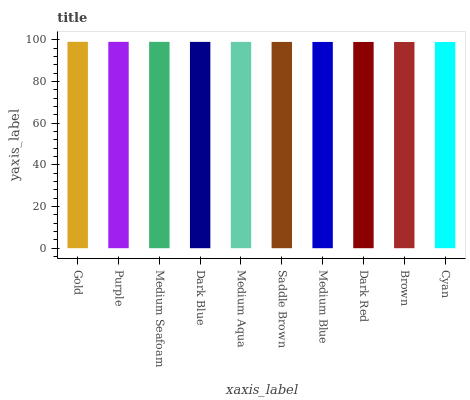Is Cyan the minimum?
Answer yes or no. Yes. Is Gold the maximum?
Answer yes or no. Yes. Is Purple the minimum?
Answer yes or no. No. Is Purple the maximum?
Answer yes or no. No. Is Gold greater than Purple?
Answer yes or no. Yes. Is Purple less than Gold?
Answer yes or no. Yes. Is Purple greater than Gold?
Answer yes or no. No. Is Gold less than Purple?
Answer yes or no. No. Is Medium Aqua the high median?
Answer yes or no. Yes. Is Saddle Brown the low median?
Answer yes or no. Yes. Is Medium Blue the high median?
Answer yes or no. No. Is Brown the low median?
Answer yes or no. No. 